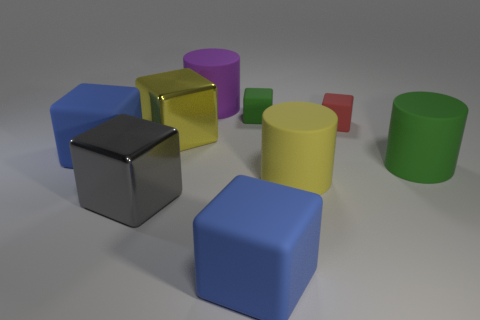Subtract all blue cubes. How many cubes are left? 4 Subtract 1 blocks. How many blocks are left? 5 Subtract all red spheres. How many blue cubes are left? 2 Subtract all blue cubes. How many cubes are left? 4 Add 1 large yellow rubber objects. How many objects exist? 10 Subtract all cyan blocks. Subtract all red spheres. How many blocks are left? 6 Subtract all cylinders. How many objects are left? 6 Add 7 yellow rubber cylinders. How many yellow rubber cylinders are left? 8 Add 9 yellow blocks. How many yellow blocks exist? 10 Subtract 0 purple cubes. How many objects are left? 9 